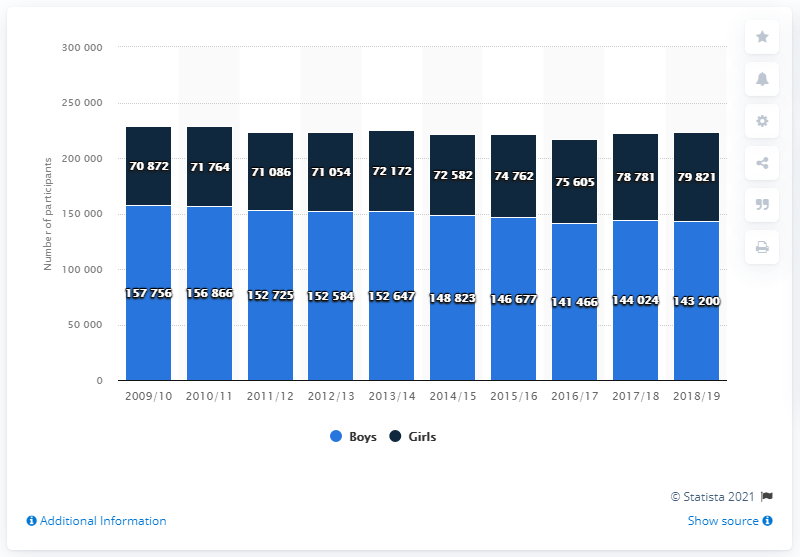Identify some key points in this picture. In the 2018/19 high school golf season, a total of 143,200 boys participated. 